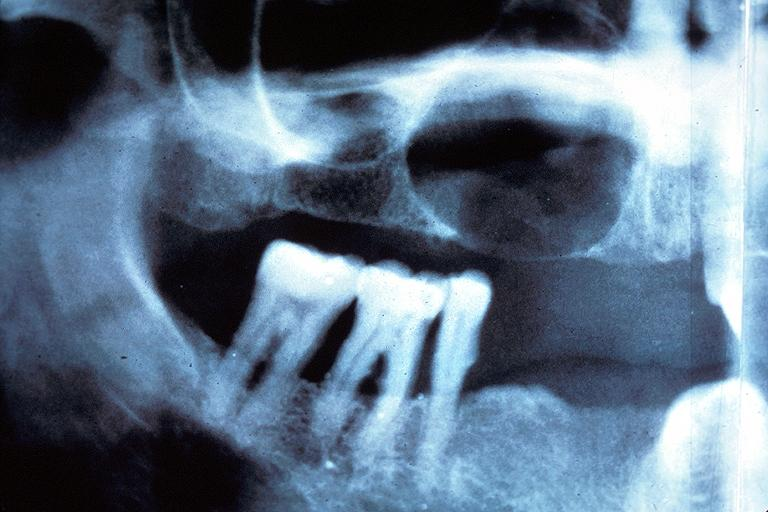s oral present?
Answer the question using a single word or phrase. Yes 